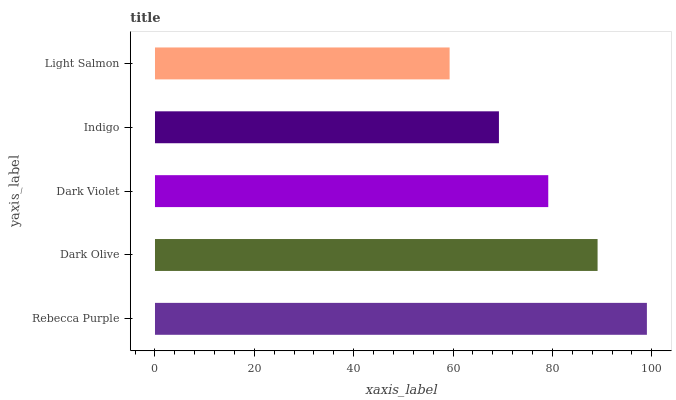Is Light Salmon the minimum?
Answer yes or no. Yes. Is Rebecca Purple the maximum?
Answer yes or no. Yes. Is Dark Olive the minimum?
Answer yes or no. No. Is Dark Olive the maximum?
Answer yes or no. No. Is Rebecca Purple greater than Dark Olive?
Answer yes or no. Yes. Is Dark Olive less than Rebecca Purple?
Answer yes or no. Yes. Is Dark Olive greater than Rebecca Purple?
Answer yes or no. No. Is Rebecca Purple less than Dark Olive?
Answer yes or no. No. Is Dark Violet the high median?
Answer yes or no. Yes. Is Dark Violet the low median?
Answer yes or no. Yes. Is Indigo the high median?
Answer yes or no. No. Is Dark Olive the low median?
Answer yes or no. No. 